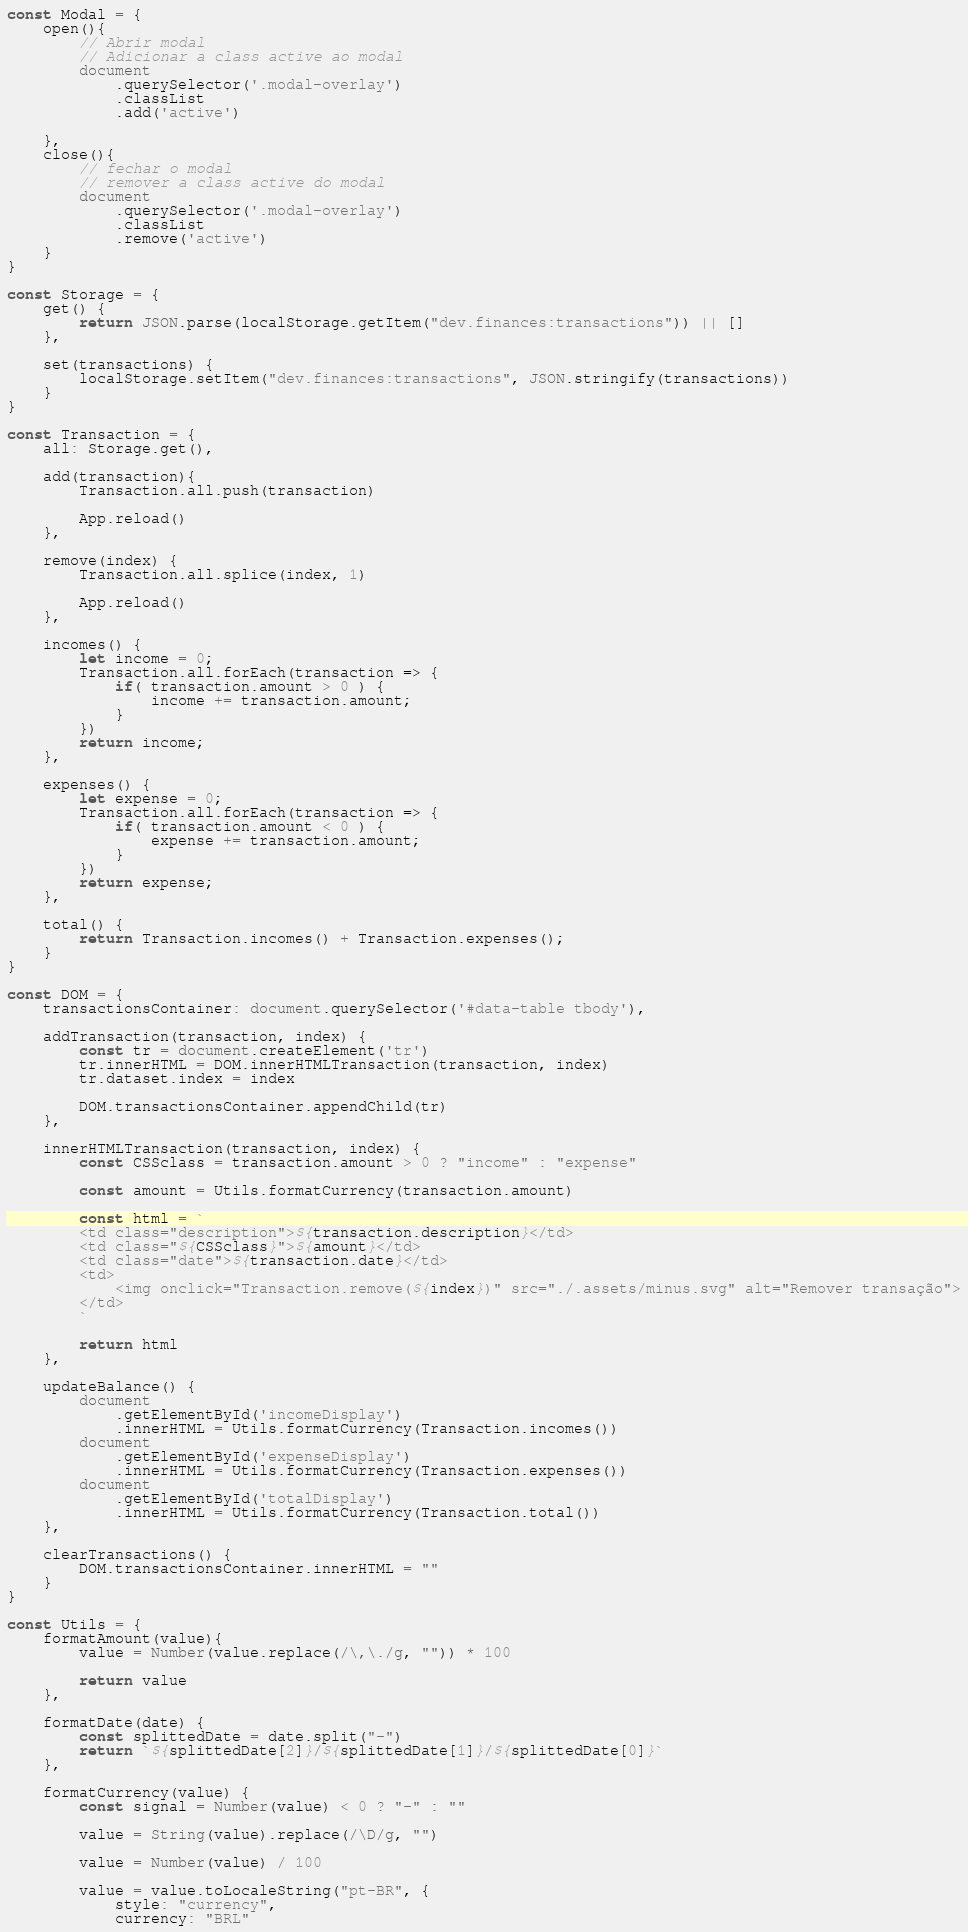Convert code to text. <code><loc_0><loc_0><loc_500><loc_500><_JavaScript_>const Modal = {
    open(){
        // Abrir modal
        // Adicionar a class active ao modal
        document
            .querySelector('.modal-overlay')
            .classList
            .add('active')

    },
    close(){
        // fechar o modal
        // remover a class active do modal
        document
            .querySelector('.modal-overlay')
            .classList
            .remove('active')
    }
}

const Storage = {
    get() {
        return JSON.parse(localStorage.getItem("dev.finances:transactions")) || []
    },

    set(transactions) {
        localStorage.setItem("dev.finances:transactions", JSON.stringify(transactions))
    }
}

const Transaction = {
    all: Storage.get(),

    add(transaction){
        Transaction.all.push(transaction)

        App.reload()
    },

    remove(index) {
        Transaction.all.splice(index, 1)

        App.reload()
    },

    incomes() {
        let income = 0;
        Transaction.all.forEach(transaction => {
            if( transaction.amount > 0 ) {
                income += transaction.amount;
            }
        })
        return income;
    },

    expenses() {
        let expense = 0;
        Transaction.all.forEach(transaction => {
            if( transaction.amount < 0 ) {
                expense += transaction.amount;
            }
        })
        return expense;
    },

    total() {
        return Transaction.incomes() + Transaction.expenses();
    }
}

const DOM = {
    transactionsContainer: document.querySelector('#data-table tbody'),

    addTransaction(transaction, index) {
        const tr = document.createElement('tr')
        tr.innerHTML = DOM.innerHTMLTransaction(transaction, index)
        tr.dataset.index = index

        DOM.transactionsContainer.appendChild(tr)
    },

    innerHTMLTransaction(transaction, index) {
        const CSSclass = transaction.amount > 0 ? "income" : "expense"

        const amount = Utils.formatCurrency(transaction.amount)

        const html = `
        <td class="description">${transaction.description}</td>
        <td class="${CSSclass}">${amount}</td>
        <td class="date">${transaction.date}</td>
        <td>
            <img onclick="Transaction.remove(${index})" src="./.assets/minus.svg" alt="Remover transação">
        </td>
        `

        return html
    },

    updateBalance() {
        document
            .getElementById('incomeDisplay')
            .innerHTML = Utils.formatCurrency(Transaction.incomes())
        document
            .getElementById('expenseDisplay')
            .innerHTML = Utils.formatCurrency(Transaction.expenses())
        document
            .getElementById('totalDisplay')
            .innerHTML = Utils.formatCurrency(Transaction.total())
    },

    clearTransactions() {
        DOM.transactionsContainer.innerHTML = ""
    }
}

const Utils = {
    formatAmount(value){
        value = Number(value.replace(/\,\./g, "")) * 100
        
        return value
    },

    formatDate(date) {
        const splittedDate = date.split("-")
        return `${splittedDate[2]}/${splittedDate[1]}/${splittedDate[0]}`
    },

    formatCurrency(value) {
        const signal = Number(value) < 0 ? "-" : ""

        value = String(value).replace(/\D/g, "")

        value = Number(value) / 100

        value = value.toLocaleString("pt-BR", {
            style: "currency",
            currency: "BRL"</code> 